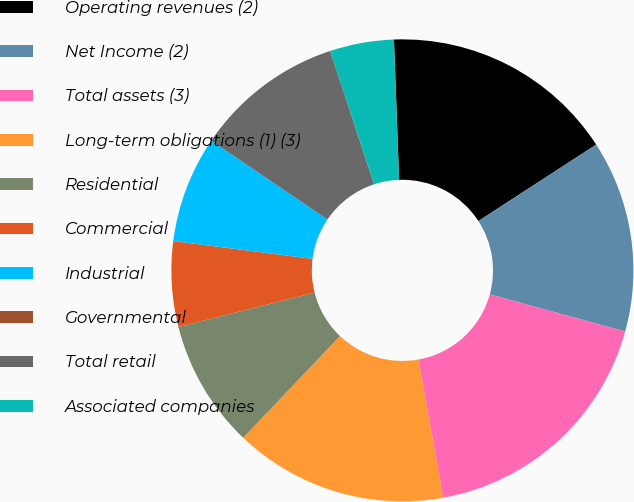<chart> <loc_0><loc_0><loc_500><loc_500><pie_chart><fcel>Operating revenues (2)<fcel>Net Income (2)<fcel>Total assets (3)<fcel>Long-term obligations (1) (3)<fcel>Residential<fcel>Commercial<fcel>Industrial<fcel>Governmental<fcel>Total retail<fcel>Associated companies<nl><fcel>16.42%<fcel>13.43%<fcel>17.91%<fcel>14.93%<fcel>8.96%<fcel>5.97%<fcel>7.46%<fcel>0.0%<fcel>10.45%<fcel>4.48%<nl></chart> 